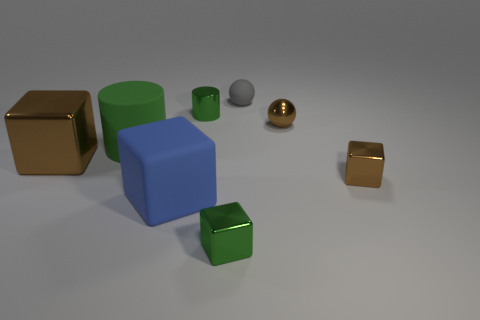Are there any gray spheres of the same size as the matte cube?
Provide a short and direct response. No. Does the large matte thing behind the large brown metal thing have the same color as the small cylinder?
Ensure brevity in your answer.  Yes. What number of things are small yellow cubes or large blocks?
Make the answer very short. 2. There is a brown object left of the green metallic cylinder; is its size the same as the blue rubber object?
Give a very brief answer. Yes. What size is the rubber object that is both to the left of the small green metal cylinder and behind the large blue thing?
Keep it short and to the point. Large. What number of other objects are the same shape as the gray matte thing?
Keep it short and to the point. 1. How many other objects are the same material as the big blue thing?
Your answer should be very brief. 2. What size is the brown object that is the same shape as the gray matte thing?
Ensure brevity in your answer.  Small. Do the metal sphere and the big metallic cube have the same color?
Offer a terse response. Yes. What color is the object that is in front of the green matte cylinder and on the left side of the blue matte block?
Keep it short and to the point. Brown. 